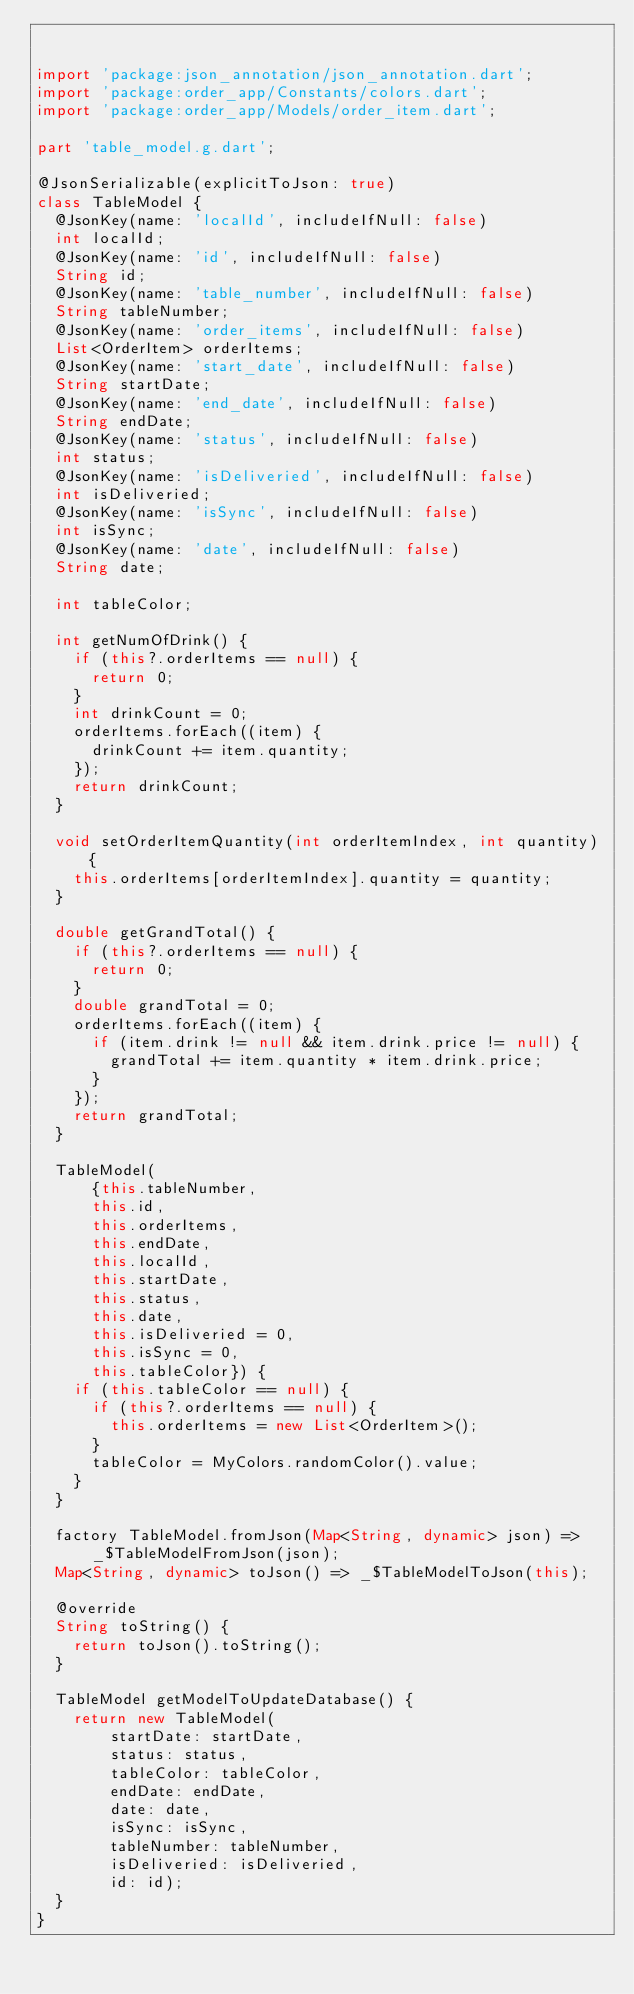<code> <loc_0><loc_0><loc_500><loc_500><_Dart_>

import 'package:json_annotation/json_annotation.dart';
import 'package:order_app/Constants/colors.dart';
import 'package:order_app/Models/order_item.dart';

part 'table_model.g.dart';

@JsonSerializable(explicitToJson: true)
class TableModel {
  @JsonKey(name: 'localId', includeIfNull: false)
  int localId;
  @JsonKey(name: 'id', includeIfNull: false)
  String id;
  @JsonKey(name: 'table_number', includeIfNull: false)
  String tableNumber;
  @JsonKey(name: 'order_items', includeIfNull: false)
  List<OrderItem> orderItems;
  @JsonKey(name: 'start_date', includeIfNull: false)
  String startDate;
  @JsonKey(name: 'end_date', includeIfNull: false)
  String endDate;
  @JsonKey(name: 'status', includeIfNull: false)
  int status;
  @JsonKey(name: 'isDeliveried', includeIfNull: false)
  int isDeliveried;
  @JsonKey(name: 'isSync', includeIfNull: false)
  int isSync;
  @JsonKey(name: 'date', includeIfNull: false)
  String date;

  int tableColor;

  int getNumOfDrink() {
    if (this?.orderItems == null) {
      return 0;
    }
    int drinkCount = 0;
    orderItems.forEach((item) {
      drinkCount += item.quantity;
    });
    return drinkCount;
  }

  void setOrderItemQuantity(int orderItemIndex, int quantity) {
    this.orderItems[orderItemIndex].quantity = quantity;
  }

  double getGrandTotal() {
    if (this?.orderItems == null) {
      return 0;
    }
    double grandTotal = 0;
    orderItems.forEach((item) {
      if (item.drink != null && item.drink.price != null) {
        grandTotal += item.quantity * item.drink.price;
      }
    });
    return grandTotal;
  }

  TableModel(
      {this.tableNumber,
      this.id,
      this.orderItems,
      this.endDate,
      this.localId,
      this.startDate,
      this.status,
      this.date,
      this.isDeliveried = 0,
      this.isSync = 0,
      this.tableColor}) {
    if (this.tableColor == null) {
      if (this?.orderItems == null) {
        this.orderItems = new List<OrderItem>();
      }
      tableColor = MyColors.randomColor().value;
    }
  }

  factory TableModel.fromJson(Map<String, dynamic> json) =>
      _$TableModelFromJson(json);
  Map<String, dynamic> toJson() => _$TableModelToJson(this);

  @override
  String toString() {
    return toJson().toString();
  }

  TableModel getModelToUpdateDatabase() {
    return new TableModel(
        startDate: startDate,
        status: status,
        tableColor: tableColor,
        endDate: endDate,
        date: date,
        isSync: isSync,
        tableNumber: tableNumber,
        isDeliveried: isDeliveried,
        id: id);
  }
}
</code> 